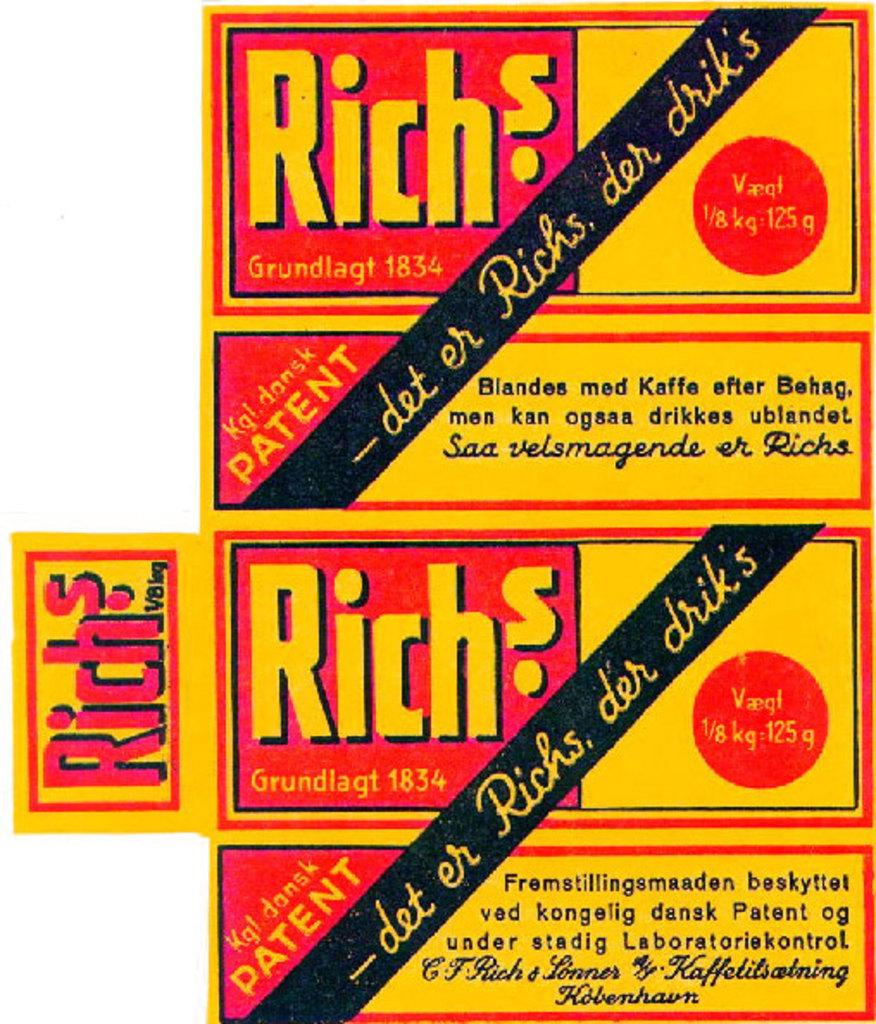<image>
Describe the image concisely. A red and yellow advertisement for Richs Grundlagt 1834 is shown. 